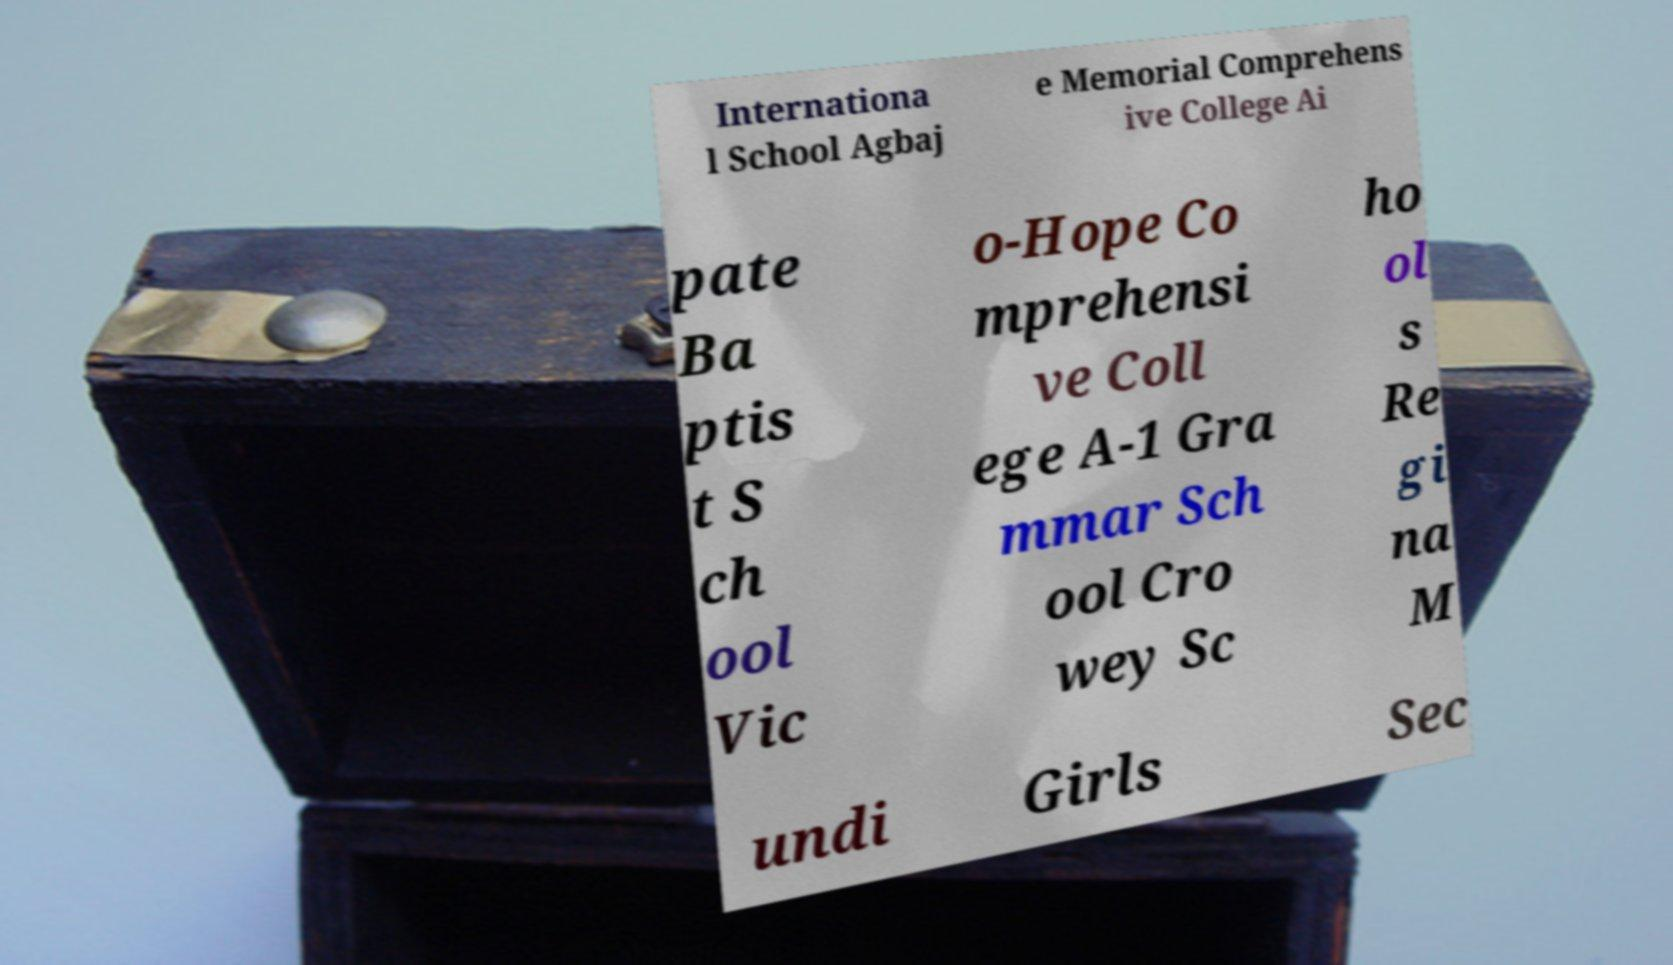Could you extract and type out the text from this image? Internationa l School Agbaj e Memorial Comprehens ive College Ai pate Ba ptis t S ch ool Vic o-Hope Co mprehensi ve Coll ege A-1 Gra mmar Sch ool Cro wey Sc ho ol s Re gi na M undi Girls Sec 